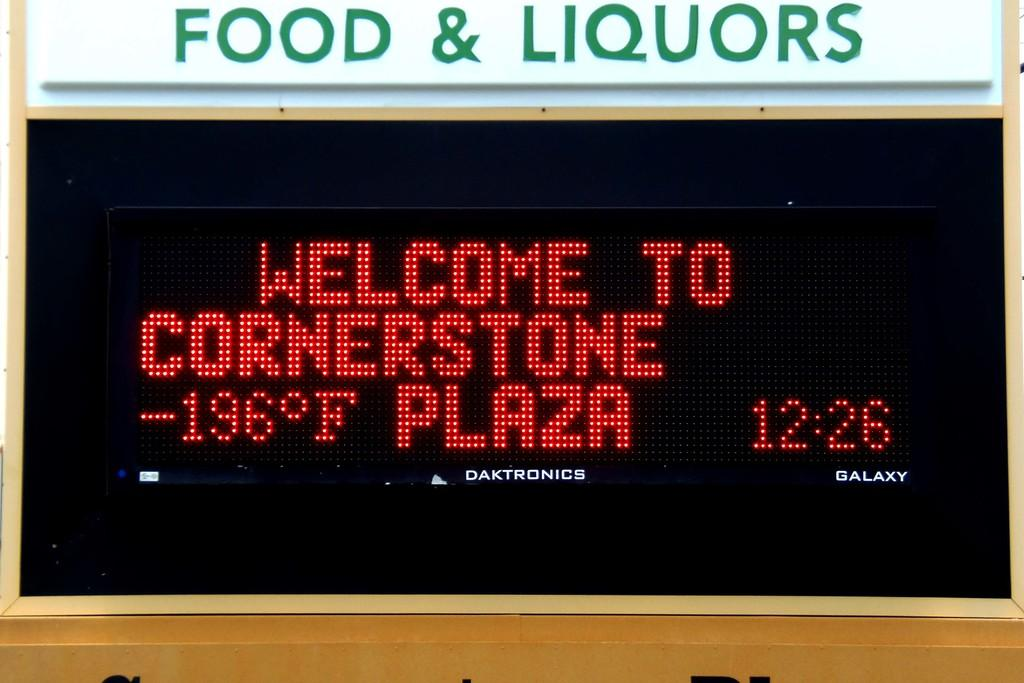Provide a one-sentence caption for the provided image. The display on a plaza information display lists the temperature as -196 degrees Fahrenheit. 